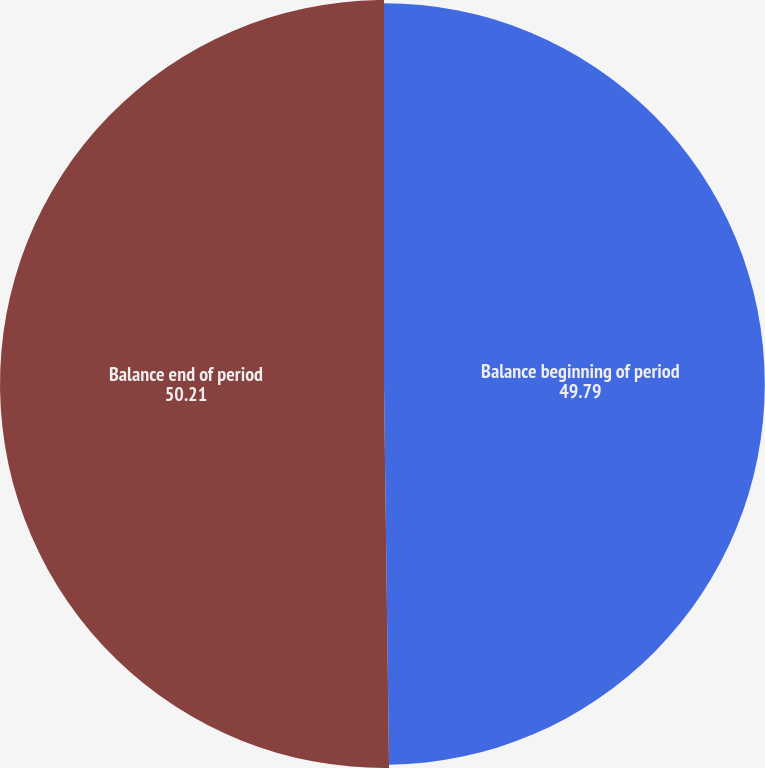<chart> <loc_0><loc_0><loc_500><loc_500><pie_chart><fcel>Balance beginning of period<fcel>Balance end of period<nl><fcel>49.79%<fcel>50.21%<nl></chart> 